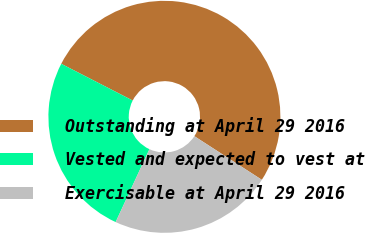Convert chart to OTSL. <chart><loc_0><loc_0><loc_500><loc_500><pie_chart><fcel>Outstanding at April 29 2016<fcel>Vested and expected to vest at<fcel>Exercisable at April 29 2016<nl><fcel>51.58%<fcel>25.65%<fcel>22.77%<nl></chart> 